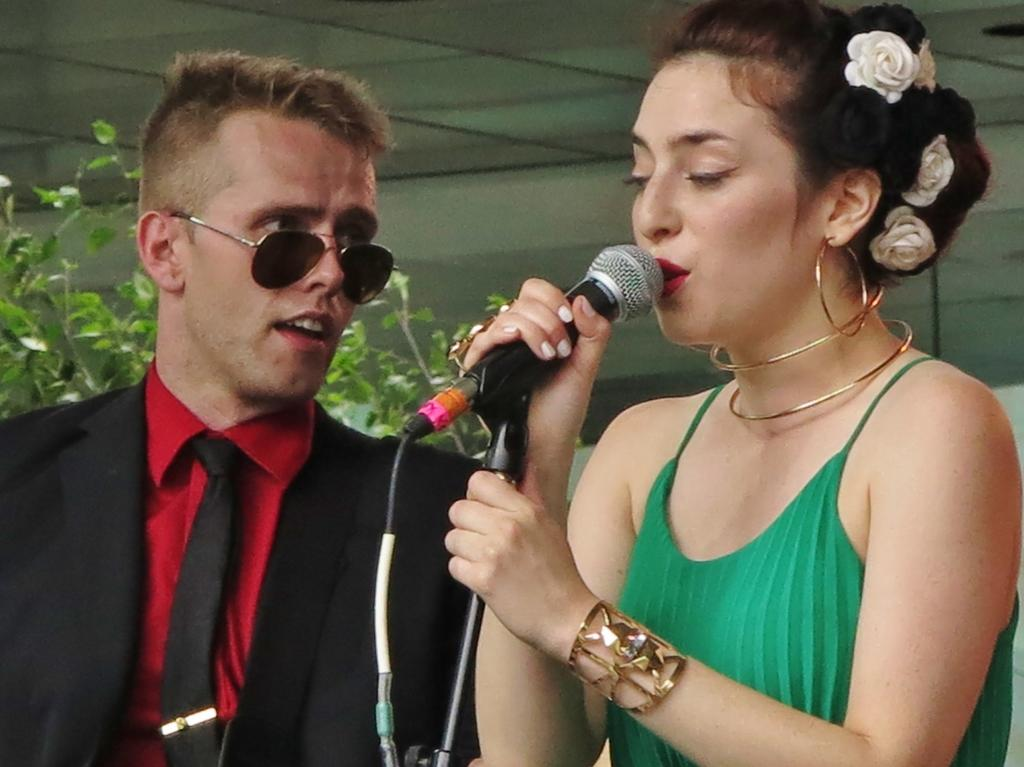What is the woman in the image doing? The woman is singing in the image. How is the woman amplifying her voice? The woman is using a microphone in the image. What is the man in the image doing? The man is watching the woman in the image. What type of vegetation can be seen in the image? There is a plant visible in the image. Can you tell me how the fog affects the woman's singing in the image? There is no fog present in the image, so it does not affect the woman's singing. Is the woman swimming while singing in the image? No, the woman is not swimming in the image; she is singing with a microphone. 